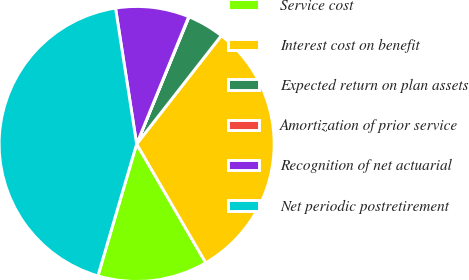<chart> <loc_0><loc_0><loc_500><loc_500><pie_chart><fcel>Service cost<fcel>Interest cost on benefit<fcel>Expected return on plan assets<fcel>Amortization of prior service<fcel>Recognition of net actuarial<fcel>Net periodic postretirement<nl><fcel>12.93%<fcel>31.06%<fcel>4.34%<fcel>0.04%<fcel>8.63%<fcel>43.0%<nl></chart> 